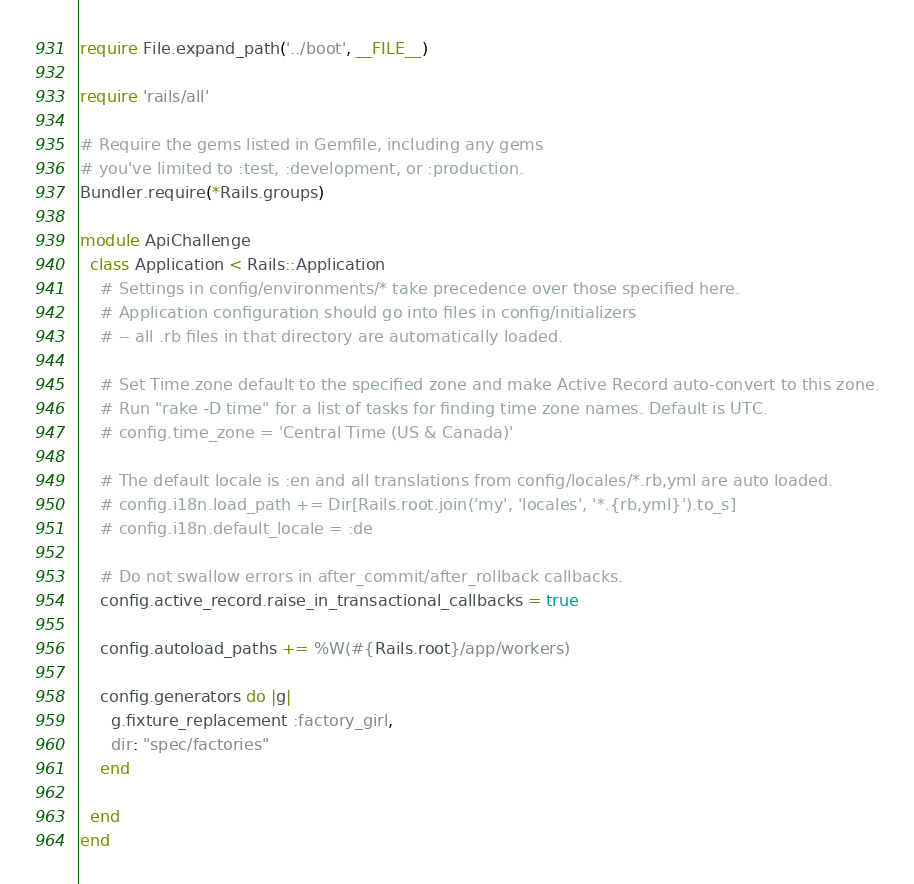<code> <loc_0><loc_0><loc_500><loc_500><_Ruby_>require File.expand_path('../boot', __FILE__)

require 'rails/all'

# Require the gems listed in Gemfile, including any gems
# you've limited to :test, :development, or :production.
Bundler.require(*Rails.groups)

module ApiChallenge
  class Application < Rails::Application
    # Settings in config/environments/* take precedence over those specified here.
    # Application configuration should go into files in config/initializers
    # -- all .rb files in that directory are automatically loaded.

    # Set Time.zone default to the specified zone and make Active Record auto-convert to this zone.
    # Run "rake -D time" for a list of tasks for finding time zone names. Default is UTC.
    # config.time_zone = 'Central Time (US & Canada)'

    # The default locale is :en and all translations from config/locales/*.rb,yml are auto loaded.
    # config.i18n.load_path += Dir[Rails.root.join('my', 'locales', '*.{rb,yml}').to_s]
    # config.i18n.default_locale = :de

    # Do not swallow errors in after_commit/after_rollback callbacks.
    config.active_record.raise_in_transactional_callbacks = true

    config.autoload_paths += %W(#{Rails.root}/app/workers)

    config.generators do |g|
      g.fixture_replacement :factory_girl,
      dir: "spec/factories"
    end

  end
end
</code> 